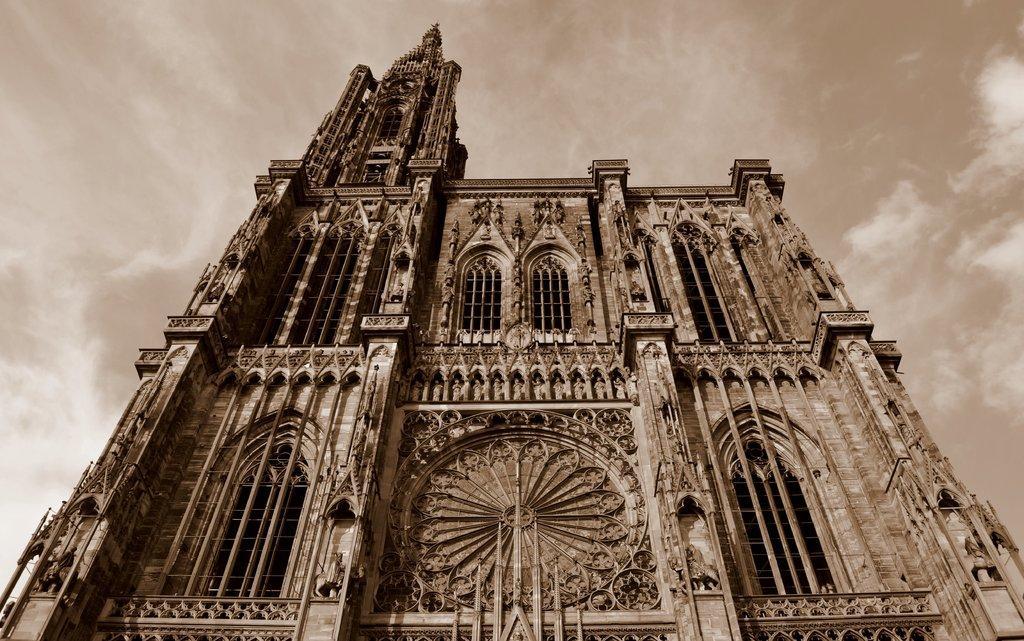Describe this image in one or two sentences. In this picture there is a fort in the front and the sky is cloudy. 